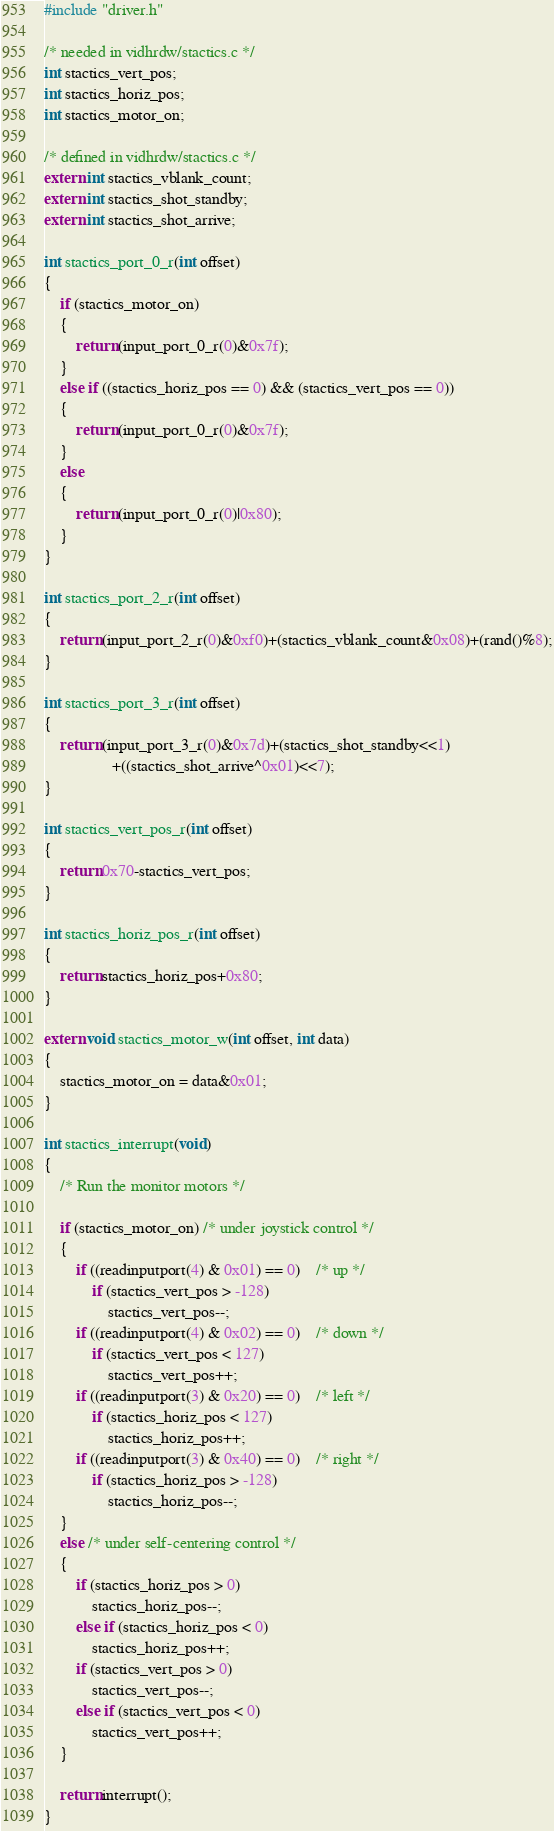<code> <loc_0><loc_0><loc_500><loc_500><_C++_>
#include "driver.h"

/* needed in vidhrdw/stactics.c */
int stactics_vert_pos;
int stactics_horiz_pos;
int stactics_motor_on;

/* defined in vidhrdw/stactics.c */
extern int stactics_vblank_count;
extern int stactics_shot_standby;
extern int stactics_shot_arrive;

int stactics_port_0_r(int offset)
{
    if (stactics_motor_on)
    {
        return (input_port_0_r(0)&0x7f);
    }
    else if ((stactics_horiz_pos == 0) && (stactics_vert_pos == 0))
    {
        return (input_port_0_r(0)&0x7f);
    }
    else
    {
        return (input_port_0_r(0)|0x80);
    }
}

int stactics_port_2_r(int offset)
{
    return (input_port_2_r(0)&0xf0)+(stactics_vblank_count&0x08)+(rand()%8);
}

int stactics_port_3_r(int offset)
{
    return (input_port_3_r(0)&0x7d)+(stactics_shot_standby<<1)
                 +((stactics_shot_arrive^0x01)<<7);
}

int stactics_vert_pos_r(int offset)
{
    return 0x70-stactics_vert_pos;
}

int stactics_horiz_pos_r(int offset)
{
    return stactics_horiz_pos+0x80;
}

extern void stactics_motor_w(int offset, int data)
{
    stactics_motor_on = data&0x01;
}

int stactics_interrupt(void)
{
    /* Run the monitor motors */

    if (stactics_motor_on) /* under joystick control */
    {
		if ((readinputport(4) & 0x01) == 0)	/* up */
			if (stactics_vert_pos > -128)
				stactics_vert_pos--;
		if ((readinputport(4) & 0x02) == 0)	/* down */
			if (stactics_vert_pos < 127)
				stactics_vert_pos++;
		if ((readinputport(3) & 0x20) == 0)	/* left */
			if (stactics_horiz_pos < 127)
				stactics_horiz_pos++;
		if ((readinputport(3) & 0x40) == 0)	/* right */
			if (stactics_horiz_pos > -128)
				stactics_horiz_pos--;
    }
    else /* under self-centering control */
    {
        if (stactics_horiz_pos > 0)
            stactics_horiz_pos--;
        else if (stactics_horiz_pos < 0)
            stactics_horiz_pos++;
        if (stactics_vert_pos > 0)
            stactics_vert_pos--;
        else if (stactics_vert_pos < 0)
            stactics_vert_pos++;
    }

    return interrupt();
}

</code> 